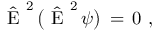Convert formula to latex. <formula><loc_0><loc_0><loc_500><loc_500>\begin{array} { r } { \hat { E } ^ { 2 } \, \left ( \hat { E } ^ { 2 } \, \psi \right ) \, = \, 0 \ , \ } \end{array}</formula> 